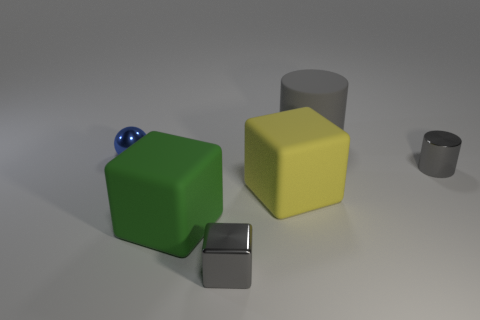Add 3 small metal things. How many objects exist? 9 Subtract all balls. How many objects are left? 5 Add 3 large gray metal blocks. How many large gray metal blocks exist? 3 Subtract 0 brown cylinders. How many objects are left? 6 Subtract all large green shiny blocks. Subtract all shiny balls. How many objects are left? 5 Add 4 shiny balls. How many shiny balls are left? 5 